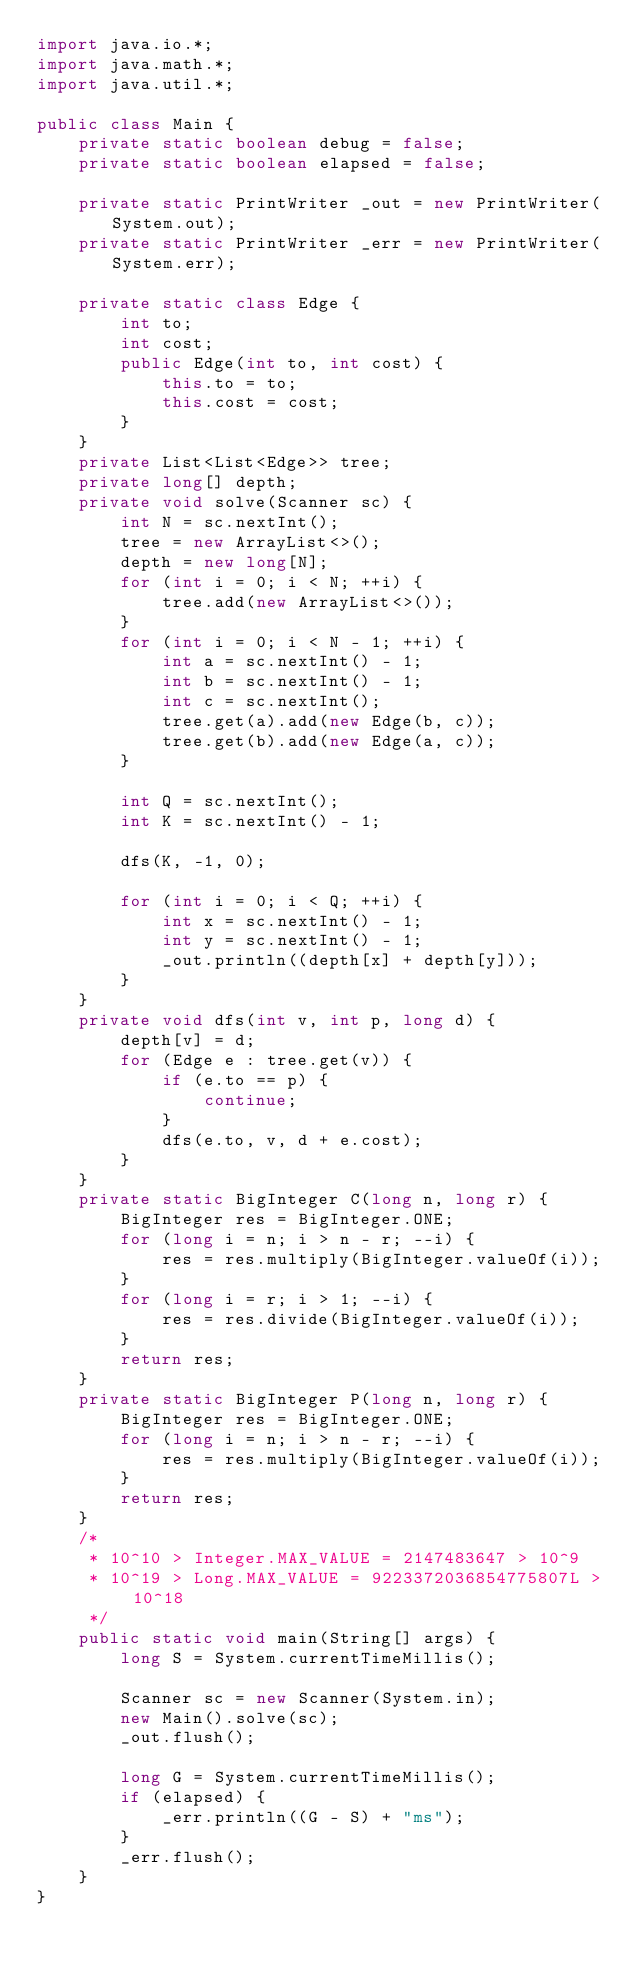Convert code to text. <code><loc_0><loc_0><loc_500><loc_500><_Java_>import java.io.*;
import java.math.*;
import java.util.*;

public class Main {
    private static boolean debug = false;
    private static boolean elapsed = false;

    private static PrintWriter _out = new PrintWriter(System.out);
    private static PrintWriter _err = new PrintWriter(System.err);

    private static class Edge {
        int to;
        int cost;
        public Edge(int to, int cost) {
            this.to = to;
            this.cost = cost;
        }
    }
    private List<List<Edge>> tree;
    private long[] depth;
    private void solve(Scanner sc) {
        int N = sc.nextInt();
        tree = new ArrayList<>();
        depth = new long[N];
        for (int i = 0; i < N; ++i) {
            tree.add(new ArrayList<>());
        }
        for (int i = 0; i < N - 1; ++i) {
            int a = sc.nextInt() - 1;
            int b = sc.nextInt() - 1;
            int c = sc.nextInt();
            tree.get(a).add(new Edge(b, c));
            tree.get(b).add(new Edge(a, c));
        }

        int Q = sc.nextInt();
        int K = sc.nextInt() - 1;

        dfs(K, -1, 0);

        for (int i = 0; i < Q; ++i) {
            int x = sc.nextInt() - 1;
            int y = sc.nextInt() - 1;
            _out.println((depth[x] + depth[y]));
        }
    }
    private void dfs(int v, int p, long d) {
        depth[v] = d;
        for (Edge e : tree.get(v)) {
            if (e.to == p) {
                continue;
            }
            dfs(e.to, v, d + e.cost);
        }
    }
    private static BigInteger C(long n, long r) {
        BigInteger res = BigInteger.ONE;
        for (long i = n; i > n - r; --i) {
            res = res.multiply(BigInteger.valueOf(i));
        }
        for (long i = r; i > 1; --i) {
            res = res.divide(BigInteger.valueOf(i));
        }
        return res;
    }
    private static BigInteger P(long n, long r) {
        BigInteger res = BigInteger.ONE;
        for (long i = n; i > n - r; --i) {
            res = res.multiply(BigInteger.valueOf(i));
        }
        return res;
    }
    /*
     * 10^10 > Integer.MAX_VALUE = 2147483647 > 10^9
     * 10^19 > Long.MAX_VALUE = 9223372036854775807L > 10^18
     */
    public static void main(String[] args) {
        long S = System.currentTimeMillis();

        Scanner sc = new Scanner(System.in);
        new Main().solve(sc);
        _out.flush();

        long G = System.currentTimeMillis();
        if (elapsed) {
            _err.println((G - S) + "ms");
        }
        _err.flush();
    }
}</code> 